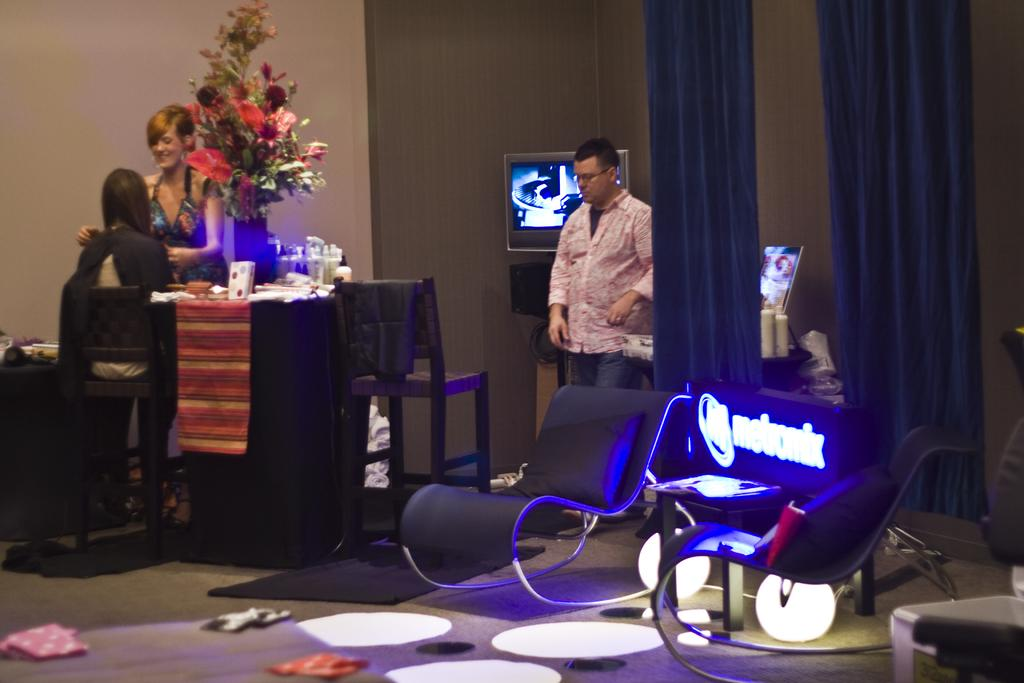How many people are in the room in the image? There are three people in the room. What furniture is present in the room? There is a chair and a table in the room. What decorative or functional items can be seen on the table? There are flowers, liquids, and two screens on the table. How many light sources are in the room? There are two lamps in the room. What type of fang can be seen in the image? There is no fang present in the image. How many fish are visible in the image? There are no fish present in the image. 